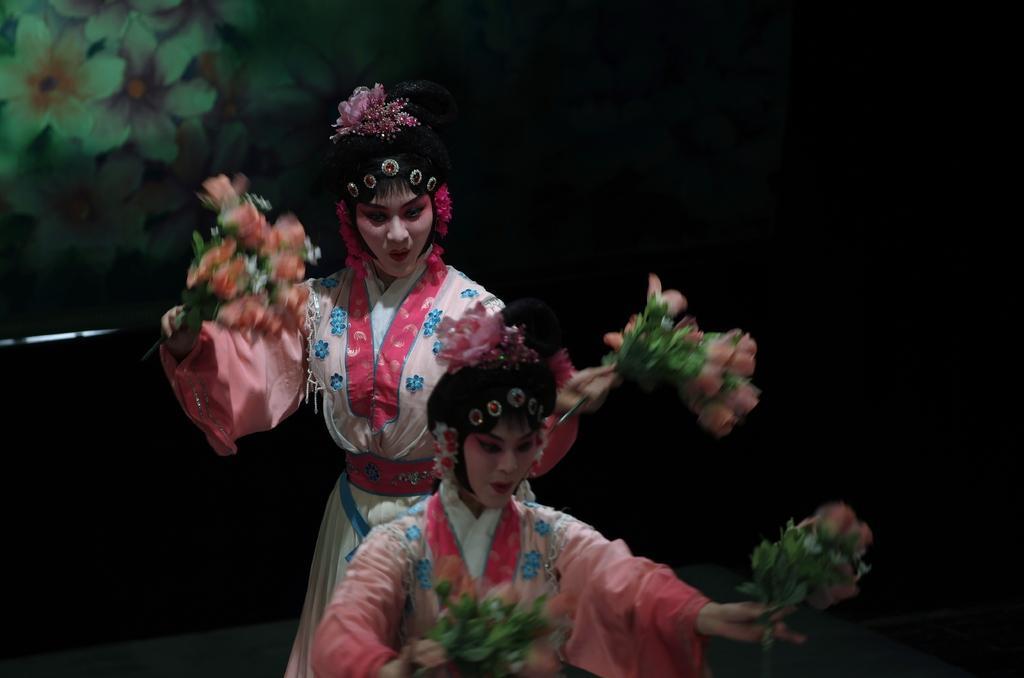In one or two sentences, can you explain what this image depicts? This picture shows two women performing an act. 